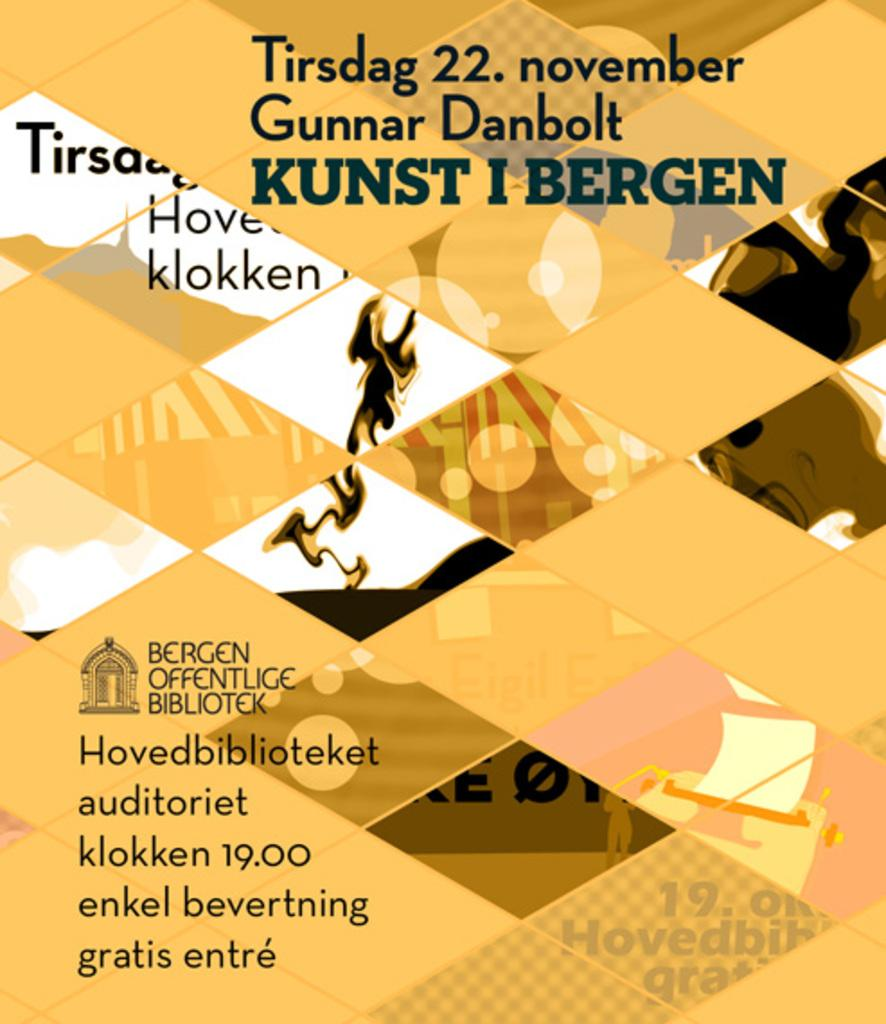<image>
Give a short and clear explanation of the subsequent image. An event at a German library has something to do with someone named Gunnar Danbolt. 